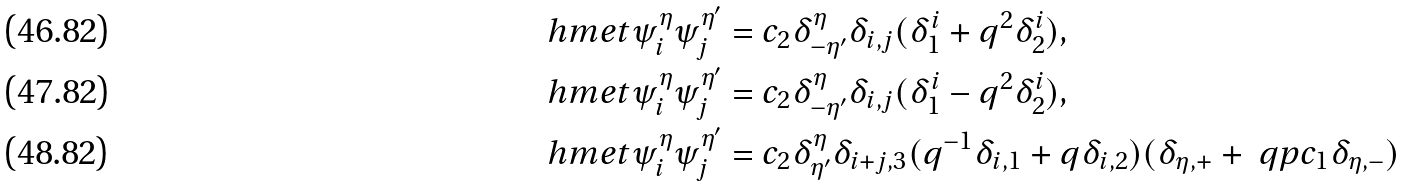<formula> <loc_0><loc_0><loc_500><loc_500>\ h m e t { \psi ^ { \eta } _ { i } } { \psi ^ { \eta ^ { \prime } } _ { j } } & = c _ { 2 } \delta ^ { \eta } _ { - \eta ^ { \prime } } \delta _ { i , j } ( \delta ^ { i } _ { 1 } + q ^ { 2 } \delta ^ { i } _ { 2 } ) , \\ \ h m e t { \psi ^ { \eta } _ { i } } { \psi ^ { \eta ^ { \prime } } _ { j } } & = c _ { 2 } \delta ^ { \eta } _ { - \eta ^ { \prime } } \delta _ { i , j } ( \delta ^ { i } _ { 1 } - q ^ { 2 } \delta ^ { i } _ { 2 } ) , \\ \ h m e t { \psi ^ { \eta } _ { i } } { \psi ^ { \eta ^ { \prime } } _ { j } } & = c _ { 2 } \delta ^ { \eta } _ { \eta ^ { \prime } } \delta _ { i + j , 3 } ( q ^ { - 1 } \delta _ { i , 1 } + q \delta _ { i , 2 } ) ( \delta _ { \eta , + } + \ q p c _ { 1 } \delta _ { \eta , - } )</formula> 